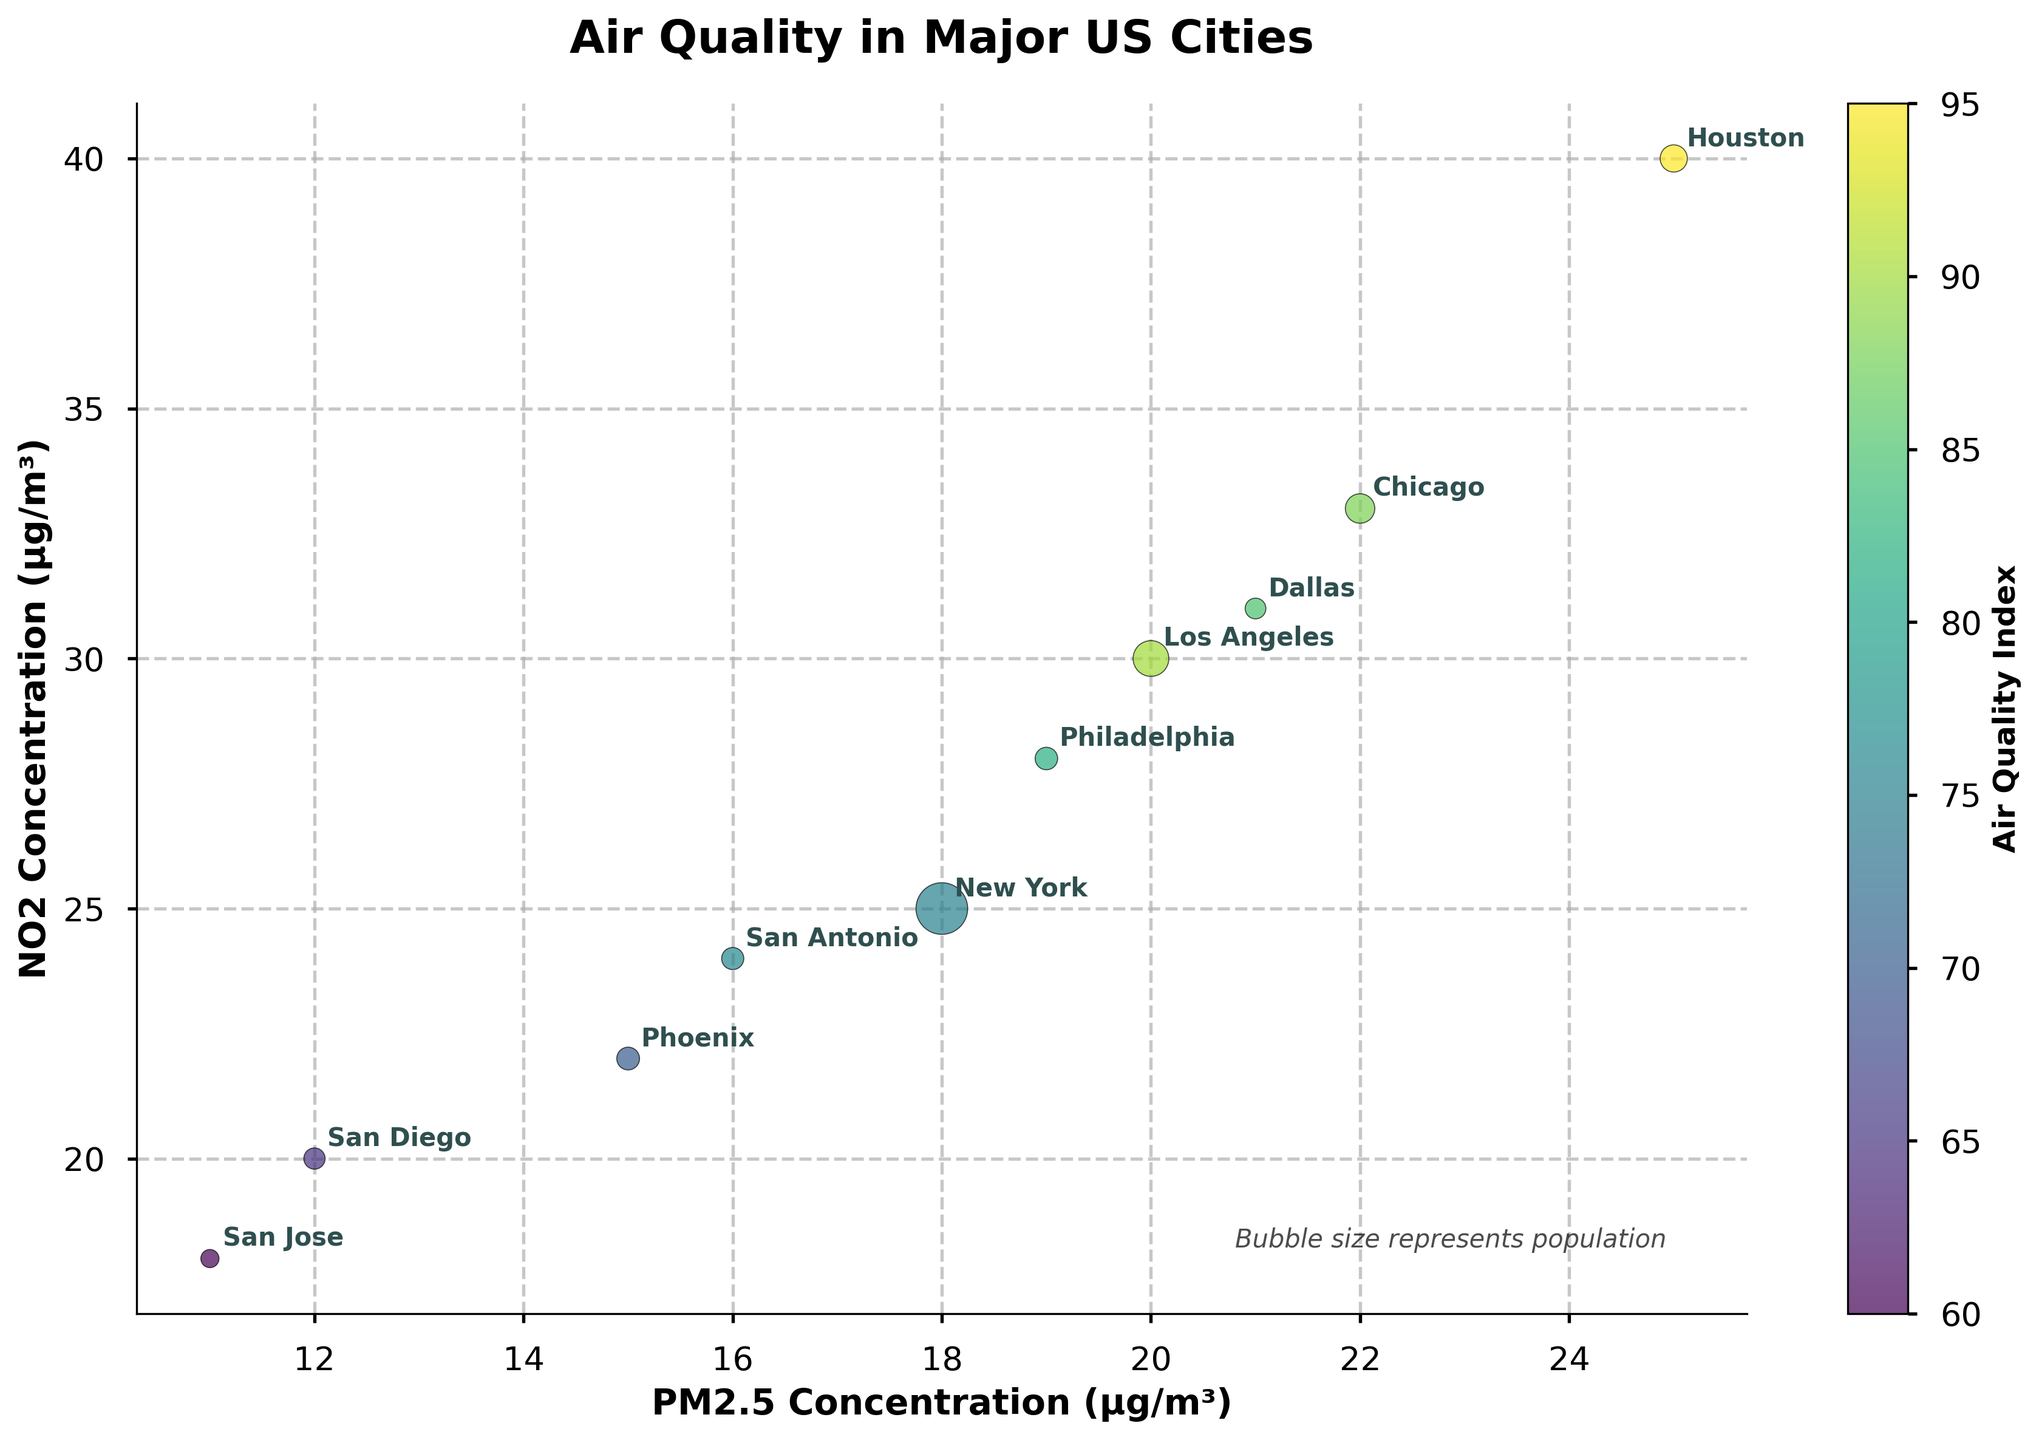What's the title of the figure? The title is at the top of the figure, clearly indicating the main theme for easy understanding. The title is "Air Quality in Major US Cities"
Answer: Air Quality in Major US Cities Which city has the highest Air Quality Index (AQI)? By looking at the color gradient representing AQI, the city with the darkest color indicates the highest AQI. Houston's bubble is the darkest.
Answer: Houston What is the range of PM2.5 concentrations observed in the figure? The x-axis represents PM2.5 concentrations, extending from the smallest to the largest circle, ranging from the minimum to the maximum value labeled. Observed from the chart, it ranges from 11 µg/m³ to 25 µg/m³.
Answer: 11 to 25 µg/m³ Which city has the smallest bubble size, indicating the smallest population? Bubble size corresponds to population size; the smallest bubble indicates the smallest population, which visually corresponds to San Jose.
Answer: San Jose What is the PM2.5 concentration for Los Angeles? Locate Los Angeles on the graph where city names are annotated near bubbles, then drop to the x-axis to determine the PM2.5 concentration. It is 20 µg/m³.
Answer: 20 µg/m³ Which two cities have the smallest difference in NO2 concentrations? Compare the y-axis positions of city bubbles, looking for two cities that are closest vertically. San Diego (20 µg/m³) and San Jose (18 µg/m³) are the closest.
Answer: San Diego and San Jose What is the average AQI for Los Angeles and New York? Find the AQI values for Los Angeles (90) and New York (75), then compute the average: (90 + 75) / 2 = 82.5
Answer: 82.5 Which city has a higher NO2 concentration: Philadelphia or San Antonio? Compare their vertical positions on the y-axis where NO2 concentration is measured. Philadelphia (28 µg/m³) is higher than San Antonio (24 µg/m³).
Answer: Philadelphia What is the annotation style used for city names on the plot? City names are labeled near their respective points on the plot with annotated text using a simple, bold font.
Answer: Bold annotated text If the population doubles, how will the bubble size for New York change? Bubble size is based on population multiplied by 50. If the population doubles, the radius of the bubble will scale by the square root of 2 (since the area factor is population). Initial population: 8.33 million, so new area = 8.33 * 2, new radius scales by √2. Visually, bubble size increases.
Answer: Increases by a factor of √2 